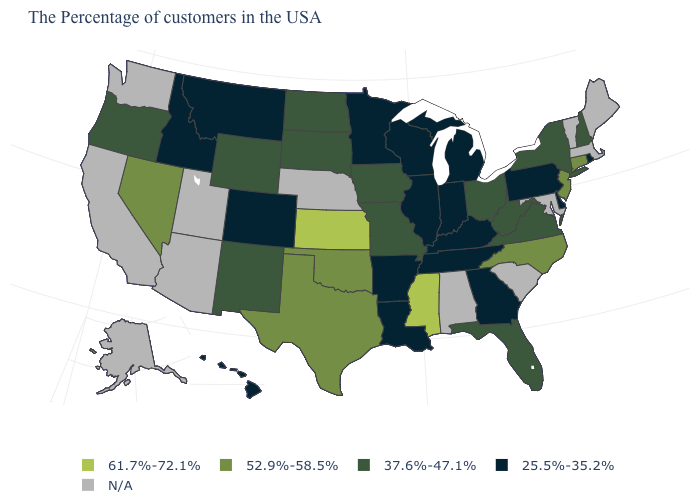What is the value of Nevada?
Keep it brief. 52.9%-58.5%. What is the value of Vermont?
Quick response, please. N/A. What is the value of West Virginia?
Answer briefly. 37.6%-47.1%. What is the value of Wisconsin?
Keep it brief. 25.5%-35.2%. How many symbols are there in the legend?
Give a very brief answer. 5. What is the value of Alaska?
Answer briefly. N/A. Does Kansas have the highest value in the USA?
Quick response, please. Yes. Name the states that have a value in the range 52.9%-58.5%?
Be succinct. Connecticut, New Jersey, North Carolina, Oklahoma, Texas, Nevada. What is the highest value in the USA?
Concise answer only. 61.7%-72.1%. Among the states that border North Carolina , does Georgia have the highest value?
Be succinct. No. What is the value of Texas?
Give a very brief answer. 52.9%-58.5%. Among the states that border Louisiana , does Mississippi have the highest value?
Quick response, please. Yes. Among the states that border Indiana , does Illinois have the lowest value?
Be succinct. Yes. How many symbols are there in the legend?
Quick response, please. 5. 